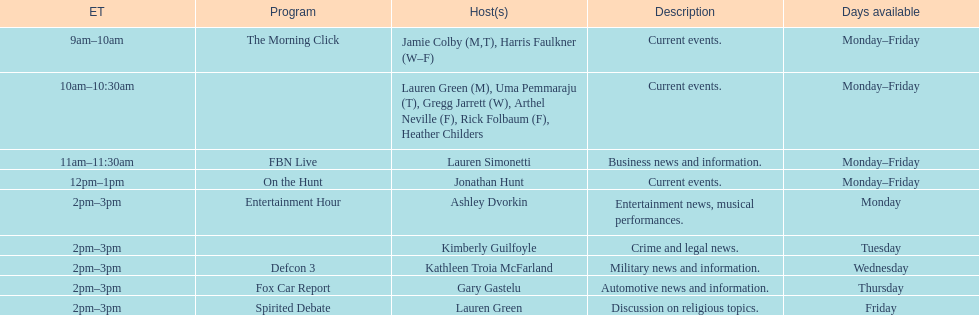What is the first show to play on monday mornings? The Morning Click. 